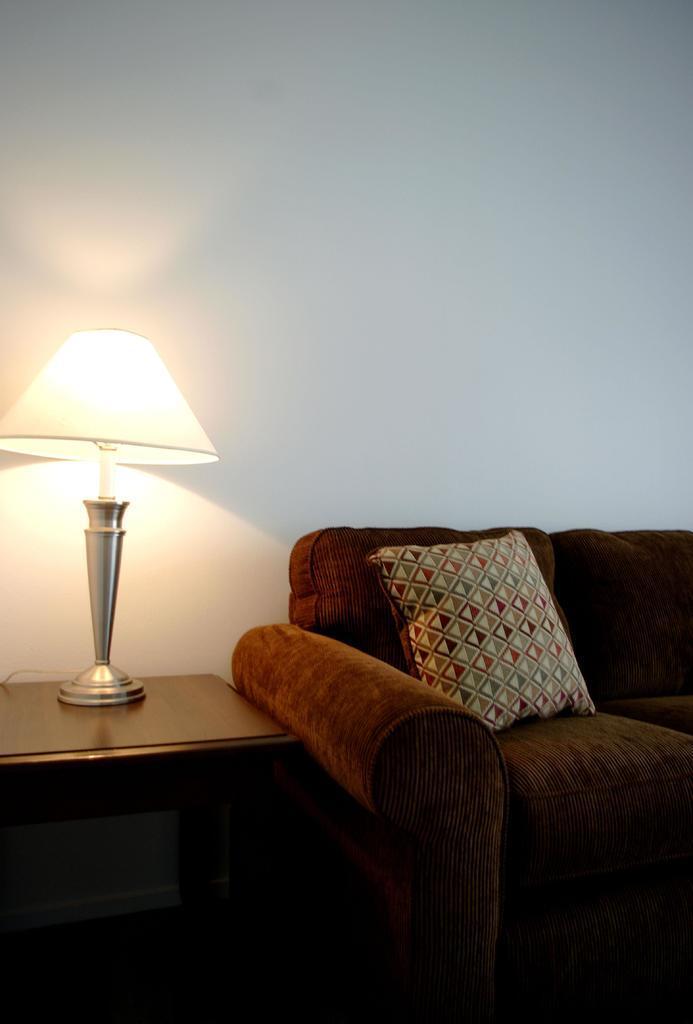How would you summarize this image in a sentence or two? here we can see a sofa set on the ground and pillows on it, and at side here is the table and lamp on it, and here is the wall. 